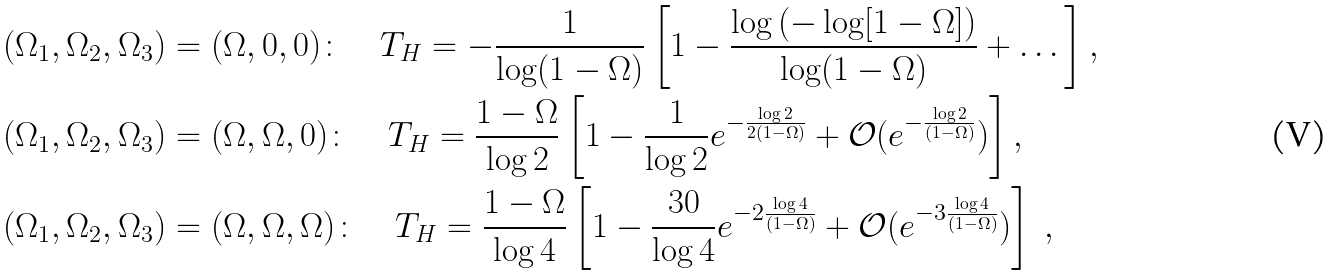<formula> <loc_0><loc_0><loc_500><loc_500>& ( \Omega _ { 1 } , \Omega _ { 2 } , \Omega _ { 3 } ) = ( \Omega , 0 , 0 ) \colon \quad T _ { H } = - \frac { 1 } { \log ( 1 - \Omega ) } \left [ 1 - \frac { \log \left ( - \log [ 1 - \Omega ] \right ) } { \log ( 1 - \Omega ) } + \dots \right ] , \\ & ( \Omega _ { 1 } , \Omega _ { 2 } , \Omega _ { 3 } ) = ( \Omega , \Omega , 0 ) \colon \quad T _ { H } = \frac { 1 - \Omega } { \log 2 } \left [ 1 - \frac { 1 } { \log 2 } e ^ { - \frac { \log 2 } { 2 ( 1 - \Omega ) } } + \mathcal { O } ( e ^ { - \frac { \log 2 } { ( 1 - \Omega ) } } ) \right ] , \\ & ( \Omega _ { 1 } , \Omega _ { 2 } , \Omega _ { 3 } ) = ( \Omega , \Omega , \Omega ) \colon \quad T _ { H } = \frac { 1 - \Omega } { \log 4 } \left [ 1 - \frac { 3 0 } { \log 4 } e ^ { - 2 \frac { \log 4 } { ( 1 - \Omega ) } } + \mathcal { O } ( e ^ { - 3 \frac { \log 4 } { ( 1 - \Omega ) } } ) \right ] \ ,</formula> 